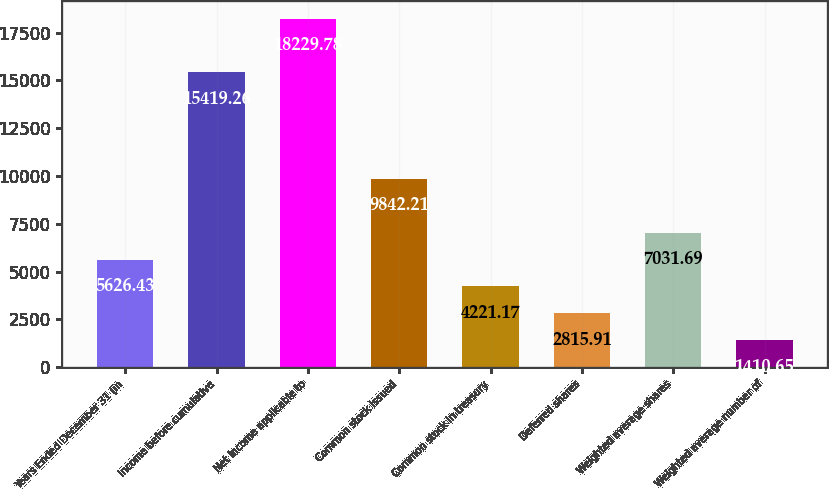Convert chart to OTSL. <chart><loc_0><loc_0><loc_500><loc_500><bar_chart><fcel>Years Ended December 31 (in<fcel>Income before cumulative<fcel>Net income applicable to<fcel>Common stock issued<fcel>Common stock in treasury<fcel>Deferred shares<fcel>Weighted average shares<fcel>Weighted average number of<nl><fcel>5626.43<fcel>15419.3<fcel>18229.8<fcel>9842.21<fcel>4221.17<fcel>2815.91<fcel>7031.69<fcel>1410.65<nl></chart> 